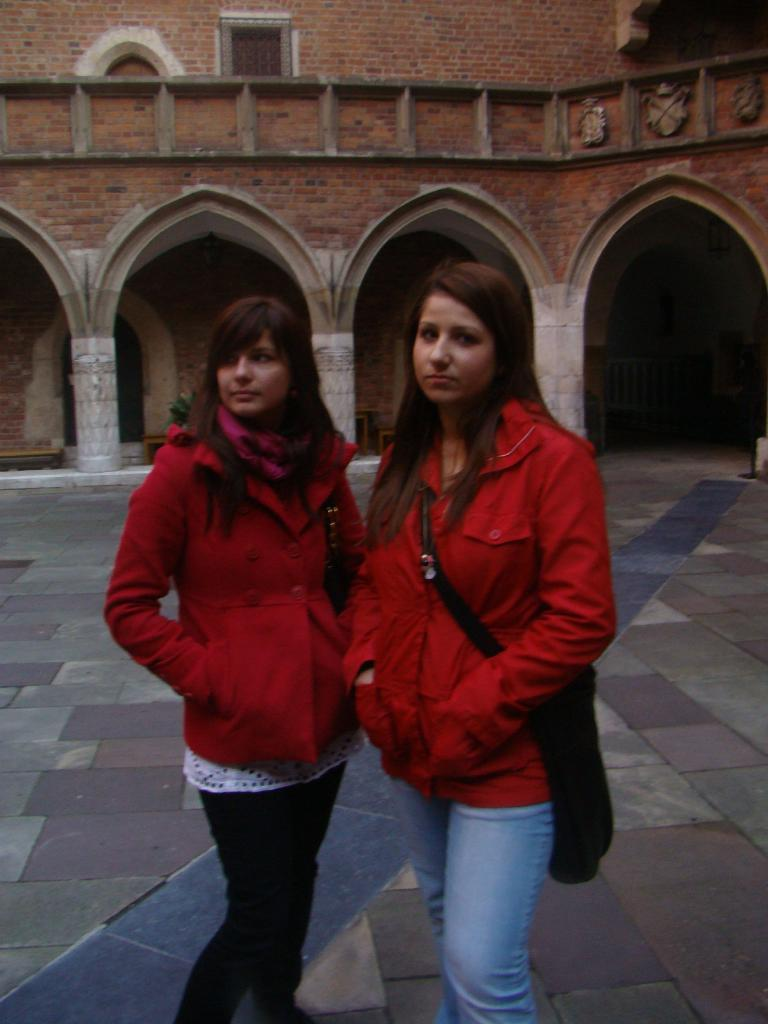How many people are in the image? There are two women in the image. What are the women doing in the image? The women are standing on a path. What can be seen in the background of the image? There is a building in the image. What architectural feature is present on the building? The building has arches. Where is the dog sitting on the throne in the image? There is no dog or throne present in the image. 